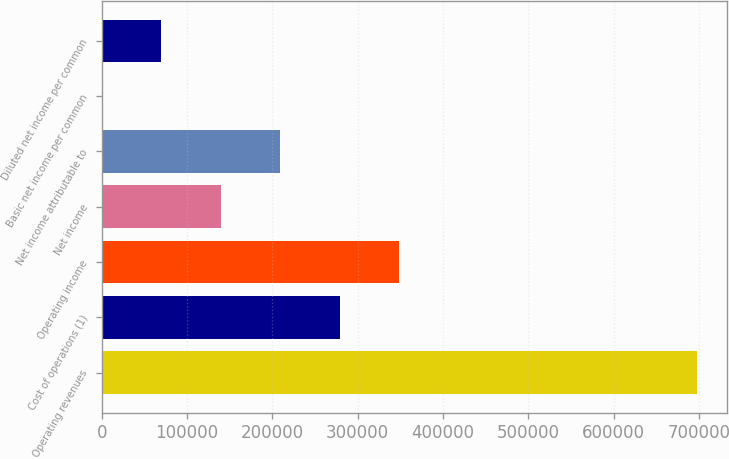<chart> <loc_0><loc_0><loc_500><loc_500><bar_chart><fcel>Operating revenues<fcel>Cost of operations (1)<fcel>Operating income<fcel>Net income<fcel>Net income attributable to<fcel>Basic net income per common<fcel>Diluted net income per common<nl><fcel>697734<fcel>279094<fcel>348867<fcel>139547<fcel>209320<fcel>0.12<fcel>69773.5<nl></chart> 